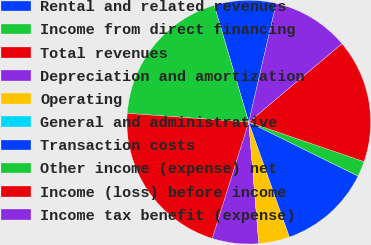Convert chart. <chart><loc_0><loc_0><loc_500><loc_500><pie_chart><fcel>Rental and related revenues<fcel>Income from direct financing<fcel>Total revenues<fcel>Depreciation and amortization<fcel>Operating<fcel>General and administrative<fcel>Transaction costs<fcel>Other income (expense) net<fcel>Income (loss) before income<fcel>Income tax benefit (expense)<nl><fcel>8.19%<fcel>19.27%<fcel>21.32%<fcel>6.15%<fcel>4.1%<fcel>0.0%<fcel>12.29%<fcel>2.05%<fcel>16.39%<fcel>10.24%<nl></chart> 